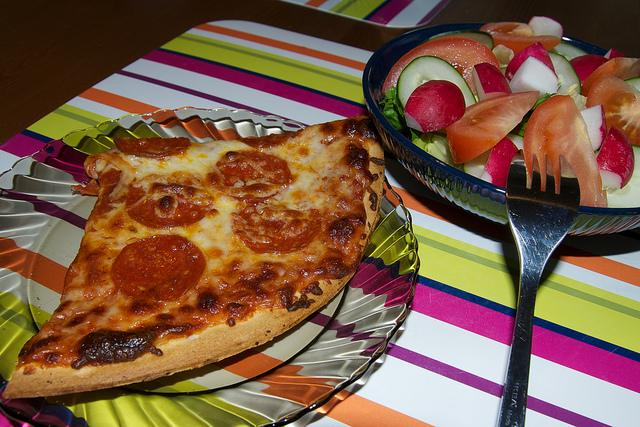What kind of side meal is there a serving of near the pizza? Please explain your reasoning. salad. There is a plate of vegetables. 